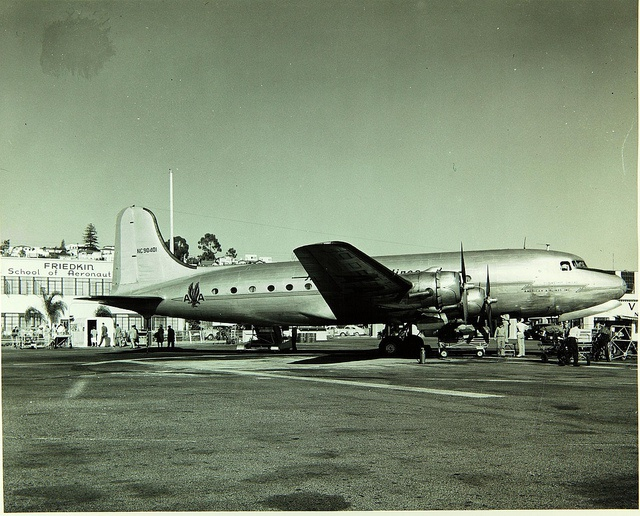Describe the objects in this image and their specific colors. I can see airplane in gray, black, beige, and darkgray tones, truck in gray, black, darkgray, and beige tones, car in gray, black, darkgray, and beige tones, people in gray, black, and beige tones, and people in gray, black, darkgreen, and darkgray tones in this image. 